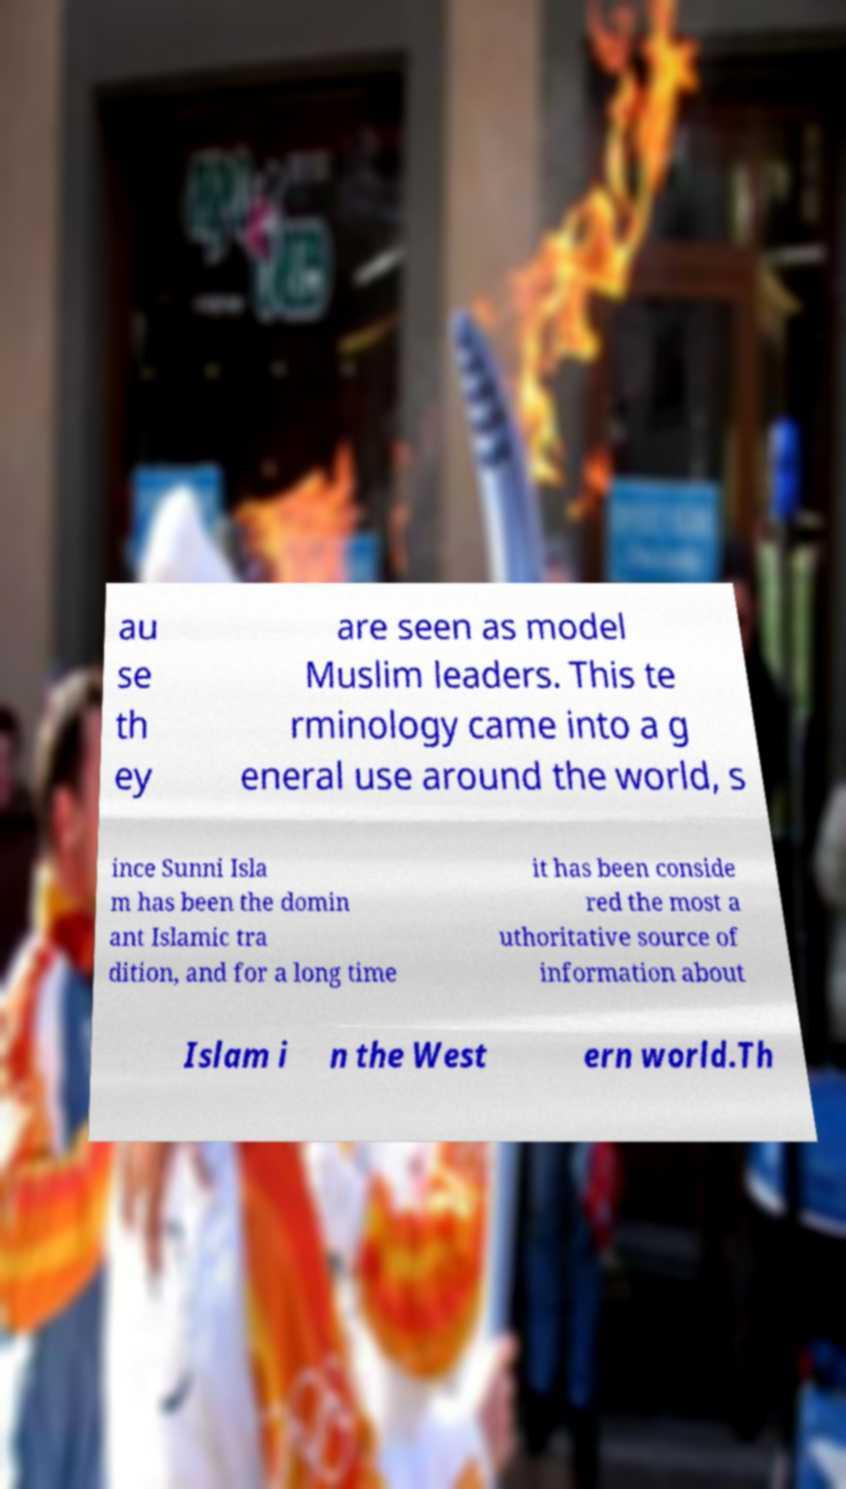I need the written content from this picture converted into text. Can you do that? au se th ey are seen as model Muslim leaders. This te rminology came into a g eneral use around the world, s ince Sunni Isla m has been the domin ant Islamic tra dition, and for a long time it has been conside red the most a uthoritative source of information about Islam i n the West ern world.Th 